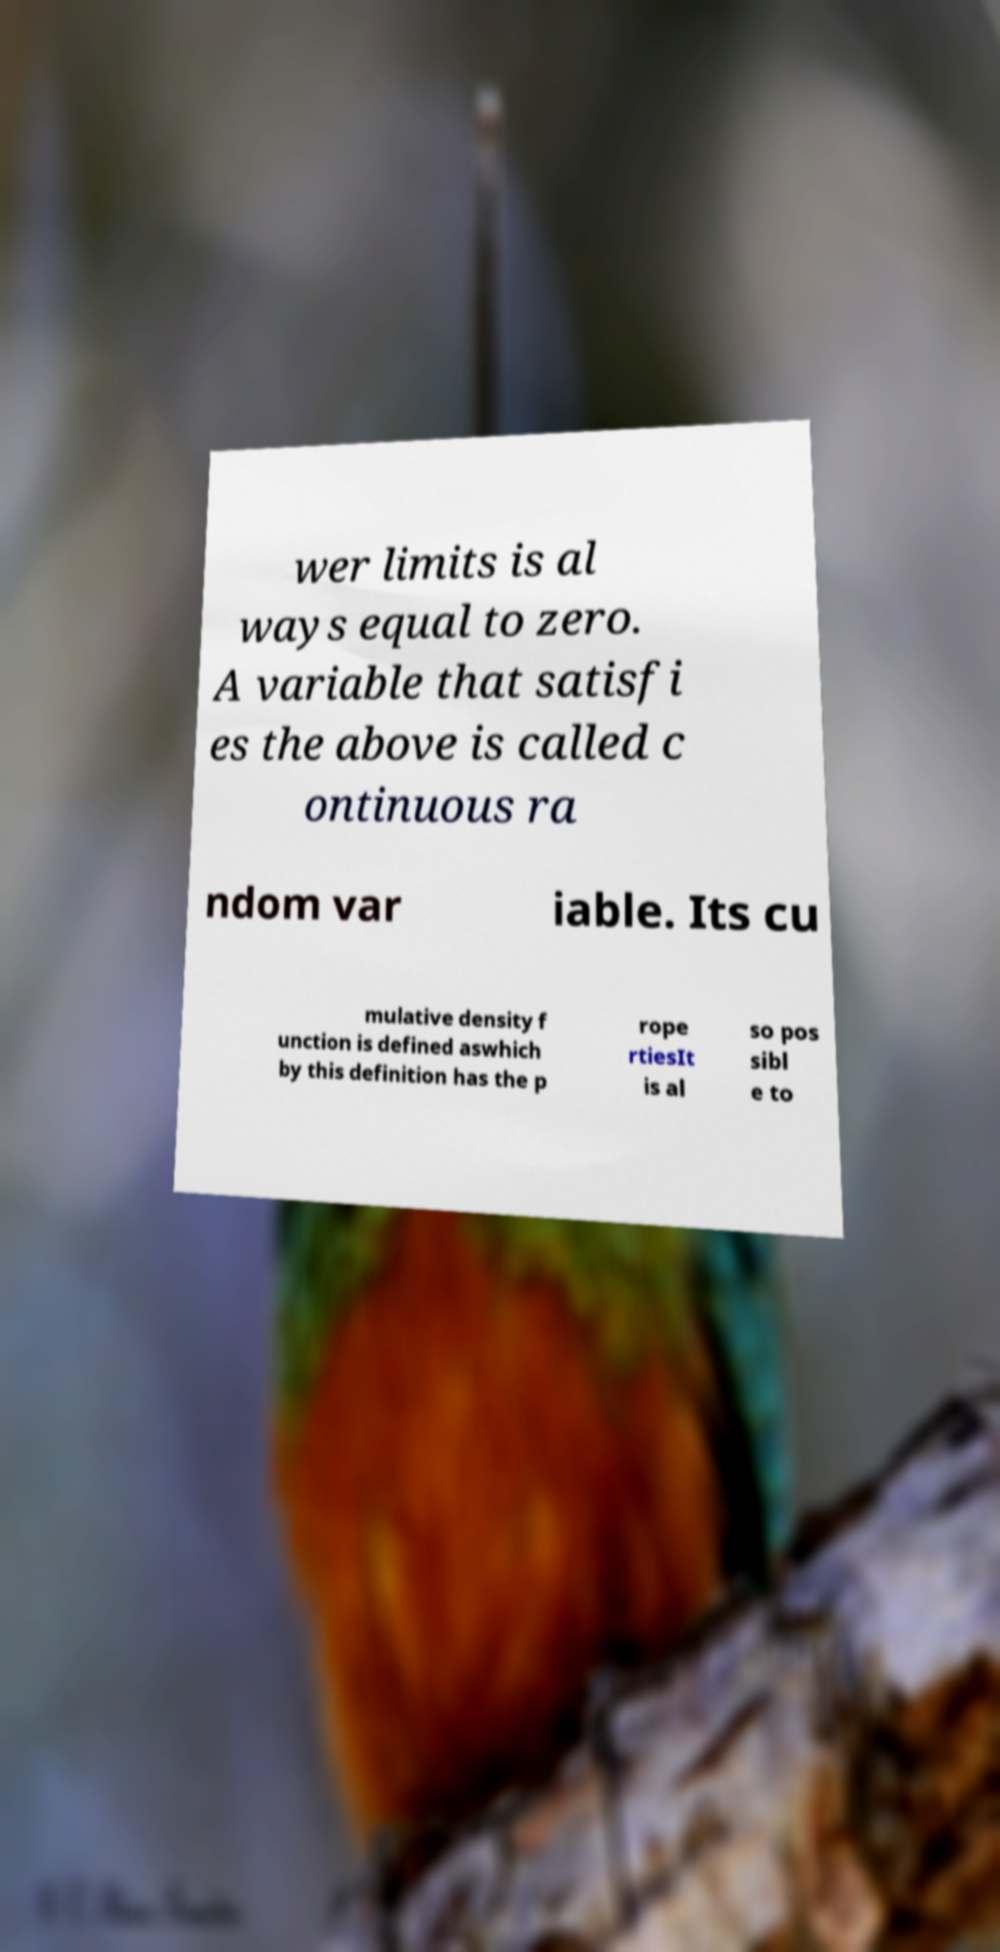I need the written content from this picture converted into text. Can you do that? wer limits is al ways equal to zero. A variable that satisfi es the above is called c ontinuous ra ndom var iable. Its cu mulative density f unction is defined aswhich by this definition has the p rope rtiesIt is al so pos sibl e to 